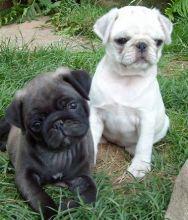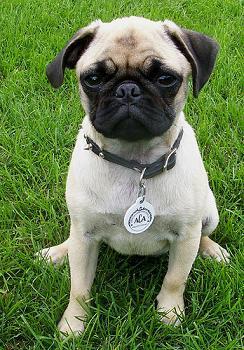The first image is the image on the left, the second image is the image on the right. Analyze the images presented: Is the assertion "All dogs are shown on green grass, and no dog is in an action pose." valid? Answer yes or no. Yes. The first image is the image on the left, the second image is the image on the right. Considering the images on both sides, is "A dog in one of the images is sitting in the grass." valid? Answer yes or no. Yes. 